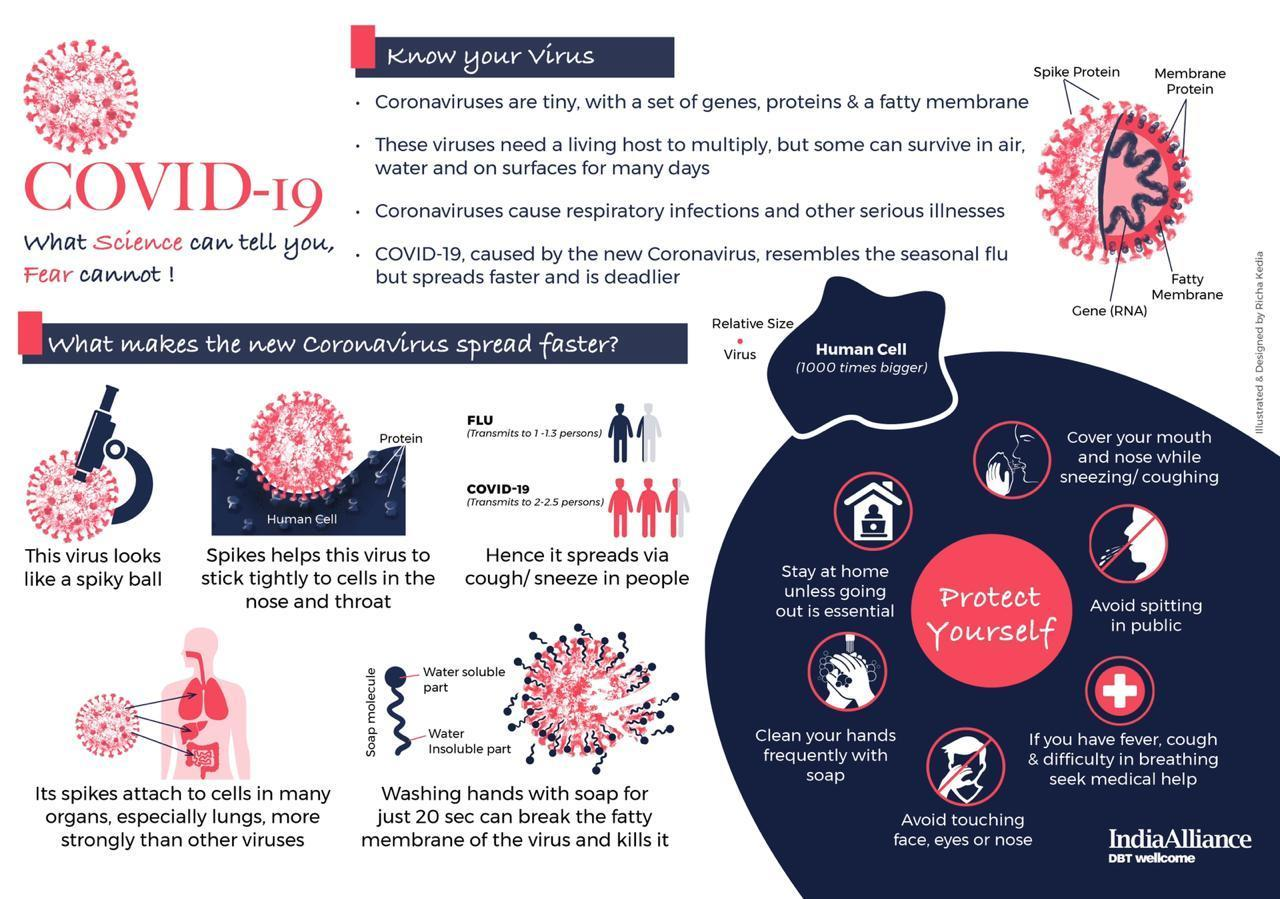Specify some key components in this picture. Four points are given under the topic 'know your virus.' Six points are given around the topic of protecting oneself. Coronaviruses are known to cause respiratory infections and serious illnesses such as the common cold, SARS, and MERS. It is important to cover your mouth and nose while sneezing or coughing in order to protect yourself and those around you from the spread of germs. It is important to protect oneself by avoiding touching the face, eyes, or nose, as highlighted at the bottom of the topic on personal safety. 